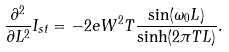<formula> <loc_0><loc_0><loc_500><loc_500>\frac { \partial ^ { 2 } } { \partial L ^ { 2 } } I _ { s t } = - 2 e W ^ { 2 } T \frac { \sin ( \omega _ { 0 } L ) } { \sinh ( 2 \pi T L ) } .</formula> 